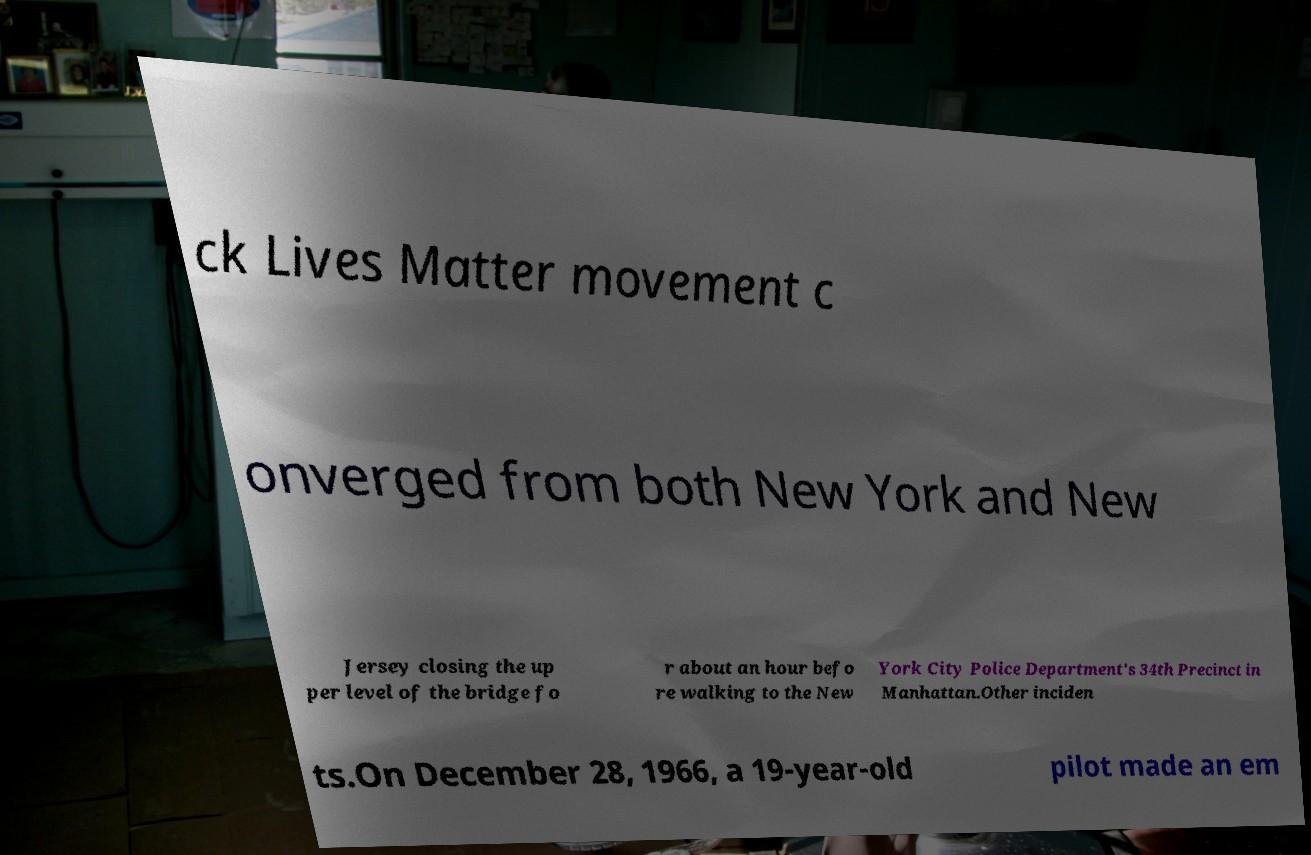What messages or text are displayed in this image? I need them in a readable, typed format. ck Lives Matter movement c onverged from both New York and New Jersey closing the up per level of the bridge fo r about an hour befo re walking to the New York City Police Department's 34th Precinct in Manhattan.Other inciden ts.On December 28, 1966, a 19-year-old pilot made an em 